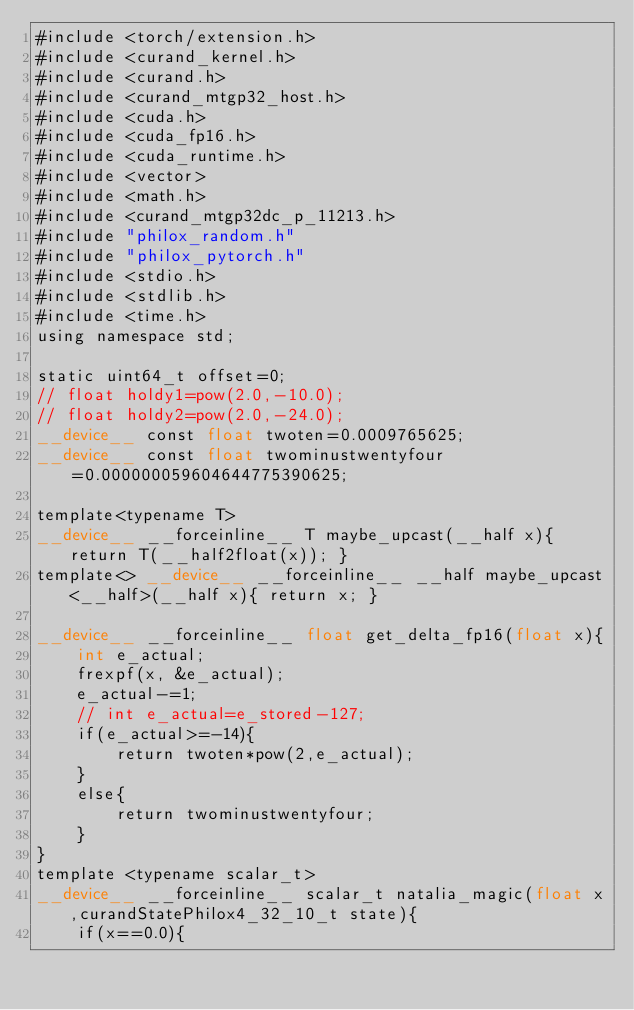Convert code to text. <code><loc_0><loc_0><loc_500><loc_500><_Cuda_>#include <torch/extension.h>
#include <curand_kernel.h>
#include <curand.h>
#include <curand_mtgp32_host.h>
#include <cuda.h>
#include <cuda_fp16.h>
#include <cuda_runtime.h>
#include <vector>
#include <math.h>
#include <curand_mtgp32dc_p_11213.h>
#include "philox_random.h"
#include "philox_pytorch.h"
#include <stdio.h>      
#include <stdlib.h>
#include <time.h>
using namespace std;

static uint64_t offset=0;
// float holdy1=pow(2.0,-10.0);
// float holdy2=pow(2.0,-24.0);
__device__ const float twoten=0.0009765625;
__device__ const float twominustwentyfour=0.000000059604644775390625;

template<typename T>
__device__ __forceinline__ T maybe_upcast(__half x){ return T(__half2float(x)); }
template<> __device__ __forceinline__ __half maybe_upcast<__half>(__half x){ return x; }

__device__ __forceinline__ float get_delta_fp16(float x){
	int e_actual;
	frexpf(x, &e_actual);
	e_actual-=1;
	// int e_actual=e_stored-127;
	if(e_actual>=-14){
		return twoten*pow(2,e_actual);
	}
	else{
		return twominustwentyfour;
	}
}
template <typename scalar_t>
__device__ __forceinline__ scalar_t natalia_magic(float x,curandStatePhilox4_32_10_t state){
 	if(x==0.0){
</code> 